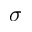<formula> <loc_0><loc_0><loc_500><loc_500>\sigma</formula> 